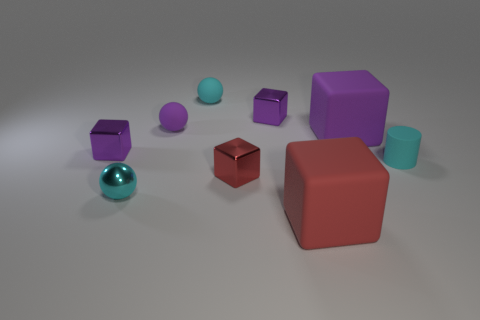How many shiny balls are the same color as the tiny cylinder?
Offer a terse response. 1. Is the shape of the purple metal thing that is left of the tiny cyan rubber ball the same as  the big purple rubber thing?
Provide a short and direct response. Yes. There is a small purple shiny thing in front of the shiny thing behind the big block that is behind the small cylinder; what shape is it?
Keep it short and to the point. Cube. What size is the cyan matte cylinder?
Give a very brief answer. Small. There is a small ball that is made of the same material as the small red thing; what is its color?
Your answer should be very brief. Cyan. How many other big purple objects have the same material as the big purple thing?
Provide a succinct answer. 0. Does the tiny cylinder have the same color as the small metal sphere in front of the large purple cube?
Provide a short and direct response. Yes. There is a shiny cube on the left side of the cyan sphere that is behind the cyan metallic thing; what is its color?
Your answer should be very brief. Purple. There is a matte block that is the same size as the red rubber object; what color is it?
Offer a very short reply. Purple. Is there a red shiny object of the same shape as the large purple matte object?
Your answer should be very brief. Yes. 